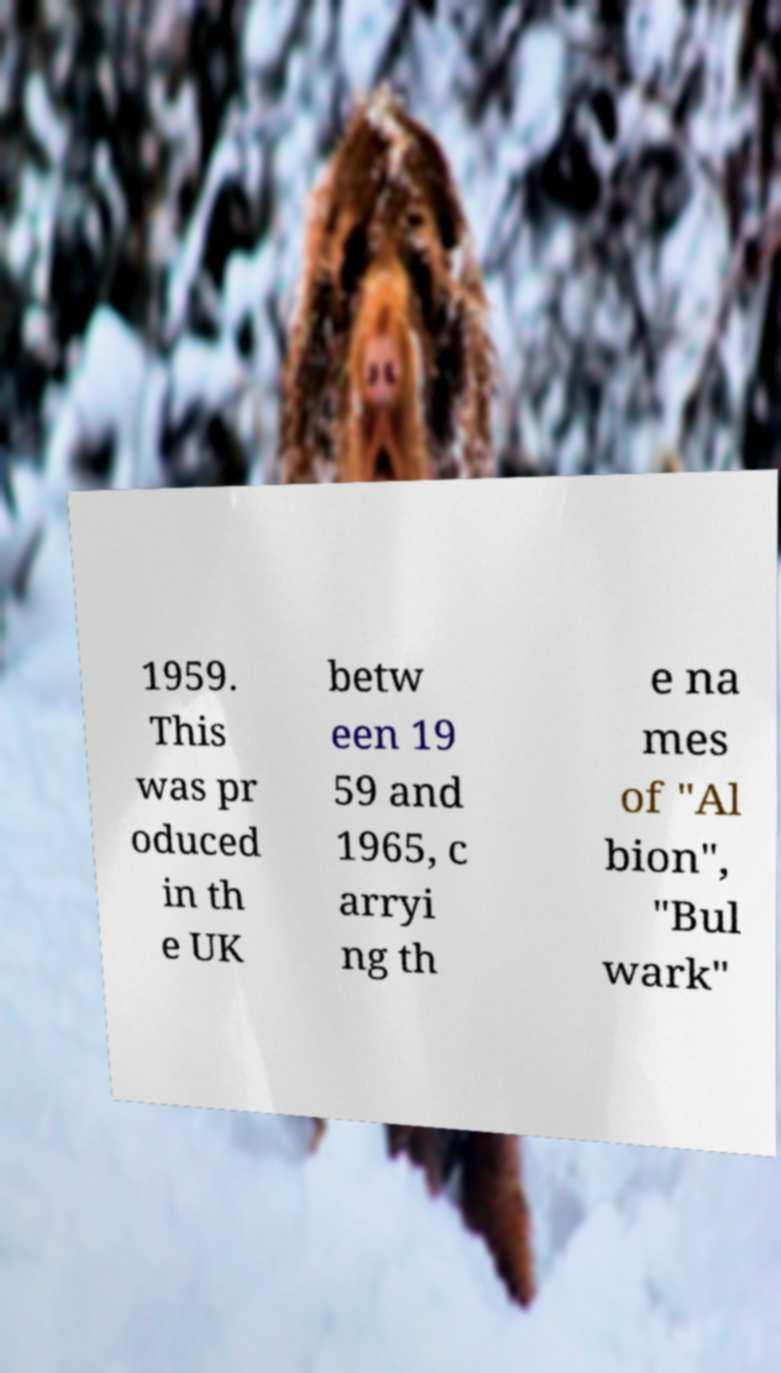I need the written content from this picture converted into text. Can you do that? 1959. This was pr oduced in th e UK betw een 19 59 and 1965, c arryi ng th e na mes of "Al bion", "Bul wark" 